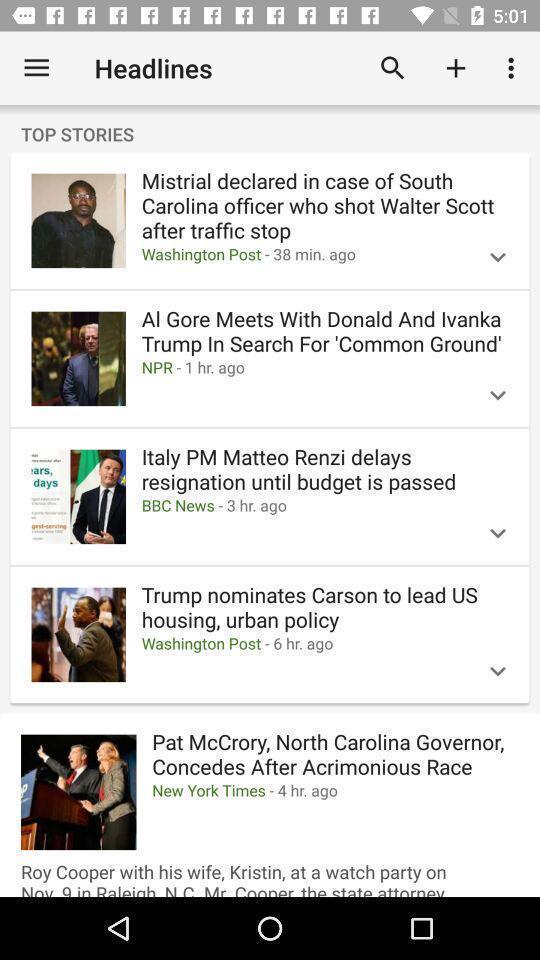Provide a textual representation of this image. Page showing different news headlines in the news app. 